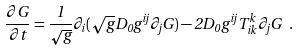Convert formula to latex. <formula><loc_0><loc_0><loc_500><loc_500>\frac { \partial G } { \partial t } = \frac { 1 } { \sqrt { g } } \partial _ { i } ( \sqrt { g } D _ { 0 } g ^ { i j } \partial _ { j } G ) - 2 D _ { 0 } g ^ { i j } T _ { i k } ^ { k } \partial _ { j } G \ .</formula> 